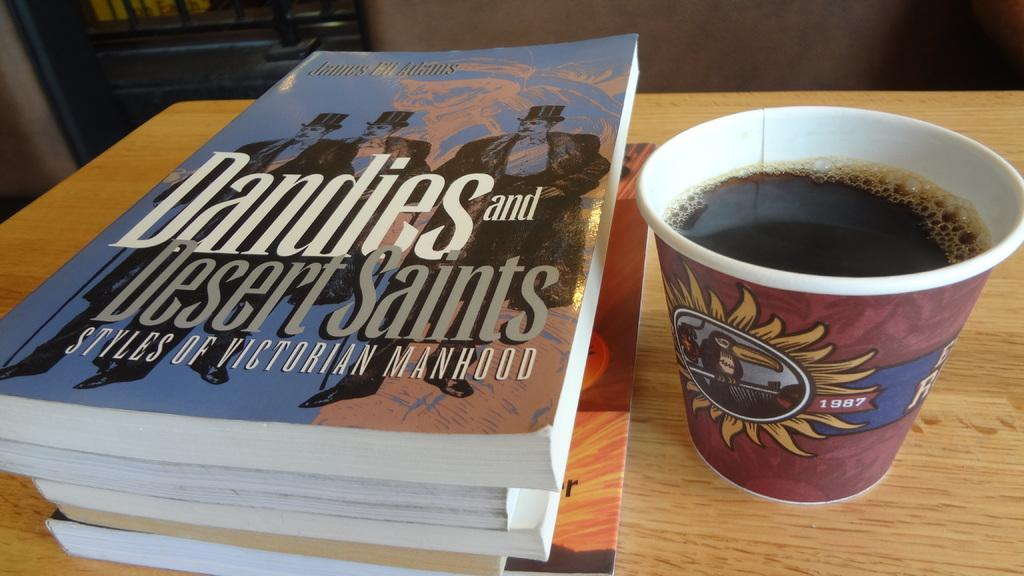<image>
Offer a succinct explanation of the picture presented. the book dandies and desert saints styles of victorian manhood sits next to a cup of coffee 